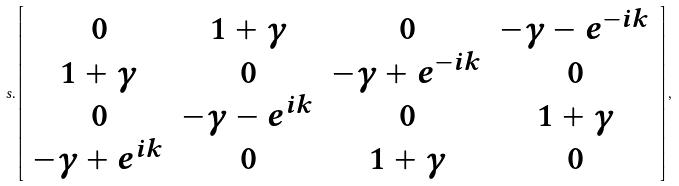<formula> <loc_0><loc_0><loc_500><loc_500>s . \left [ \begin{array} { c c c c } 0 & 1 + \gamma & 0 & - \gamma - e ^ { - i k } \\ 1 + \gamma & 0 & - \gamma + e ^ { - i k } & 0 \\ 0 & - \gamma - e ^ { i k } & 0 & 1 + \gamma \\ - \gamma + e ^ { i k } & 0 & 1 + \gamma & 0 \\ \end{array} \right ] ,</formula> 